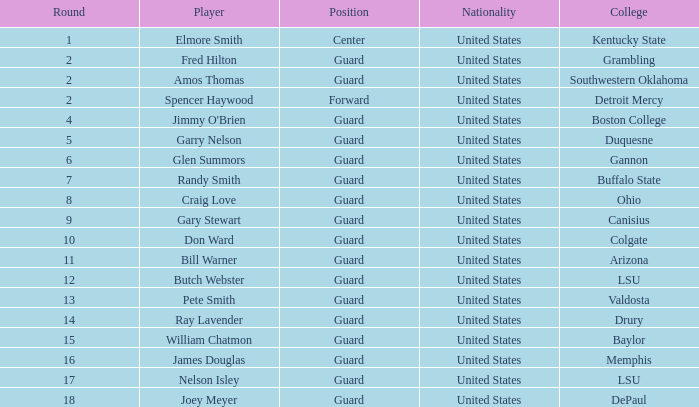WHAT COLLEGE HAS A ROUND LARGER THAN 9, WITH BUTCH WEBSTER? LSU. Give me the full table as a dictionary. {'header': ['Round', 'Player', 'Position', 'Nationality', 'College'], 'rows': [['1', 'Elmore Smith', 'Center', 'United States', 'Kentucky State'], ['2', 'Fred Hilton', 'Guard', 'United States', 'Grambling'], ['2', 'Amos Thomas', 'Guard', 'United States', 'Southwestern Oklahoma'], ['2', 'Spencer Haywood', 'Forward', 'United States', 'Detroit Mercy'], ['4', "Jimmy O'Brien", 'Guard', 'United States', 'Boston College'], ['5', 'Garry Nelson', 'Guard', 'United States', 'Duquesne'], ['6', 'Glen Summors', 'Guard', 'United States', 'Gannon'], ['7', 'Randy Smith', 'Guard', 'United States', 'Buffalo State'], ['8', 'Craig Love', 'Guard', 'United States', 'Ohio'], ['9', 'Gary Stewart', 'Guard', 'United States', 'Canisius'], ['10', 'Don Ward', 'Guard', 'United States', 'Colgate'], ['11', 'Bill Warner', 'Guard', 'United States', 'Arizona'], ['12', 'Butch Webster', 'Guard', 'United States', 'LSU'], ['13', 'Pete Smith', 'Guard', 'United States', 'Valdosta'], ['14', 'Ray Lavender', 'Guard', 'United States', 'Drury'], ['15', 'William Chatmon', 'Guard', 'United States', 'Baylor'], ['16', 'James Douglas', 'Guard', 'United States', 'Memphis'], ['17', 'Nelson Isley', 'Guard', 'United States', 'LSU'], ['18', 'Joey Meyer', 'Guard', 'United States', 'DePaul']]} 